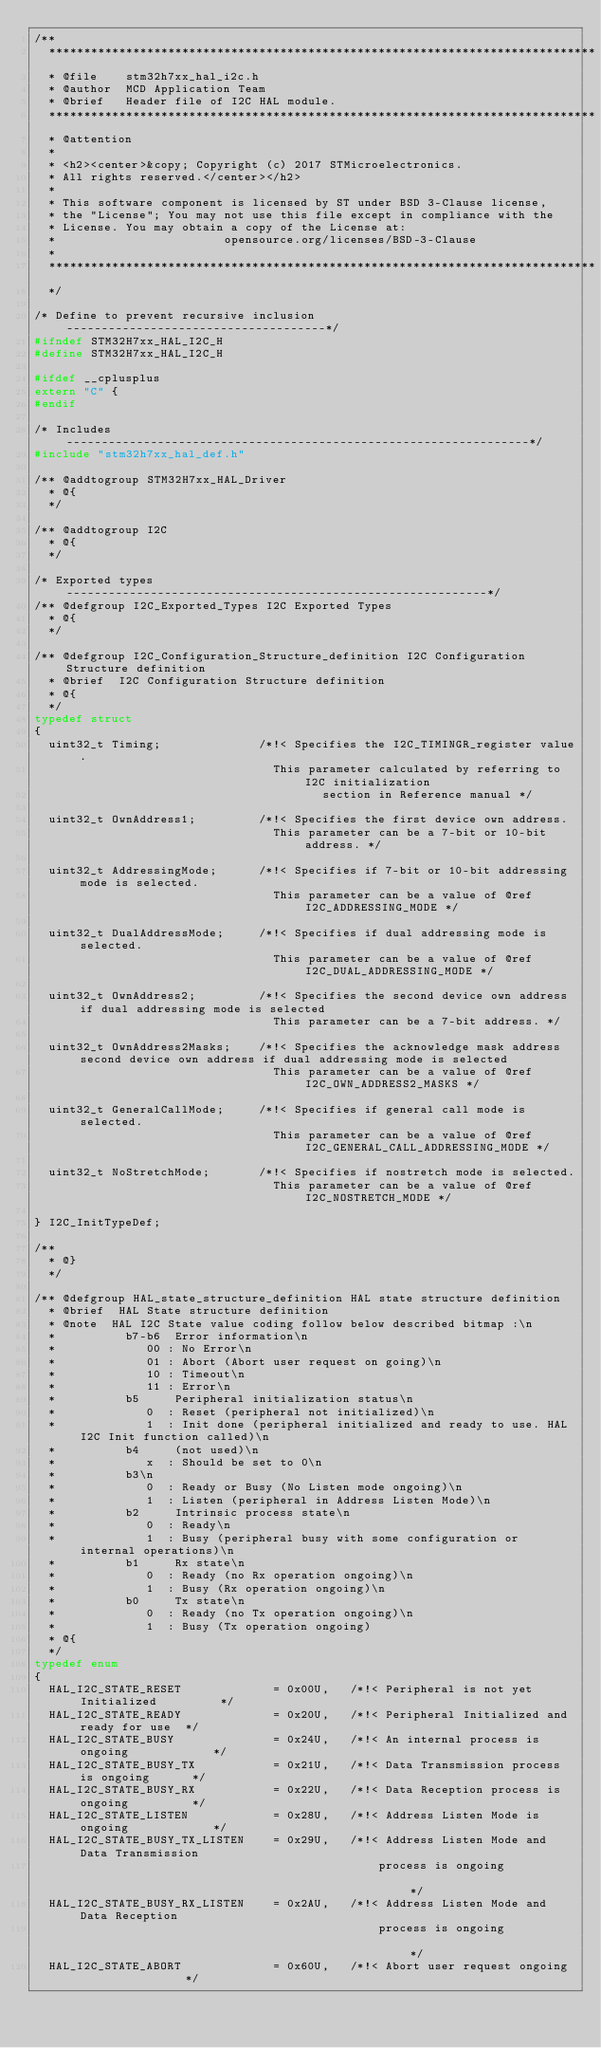<code> <loc_0><loc_0><loc_500><loc_500><_C_>/**
  ******************************************************************************
  * @file    stm32h7xx_hal_i2c.h
  * @author  MCD Application Team
  * @brief   Header file of I2C HAL module.
  ******************************************************************************
  * @attention
  *
  * <h2><center>&copy; Copyright (c) 2017 STMicroelectronics.
  * All rights reserved.</center></h2>
  *
  * This software component is licensed by ST under BSD 3-Clause license,
  * the "License"; You may not use this file except in compliance with the
  * License. You may obtain a copy of the License at:
  *                        opensource.org/licenses/BSD-3-Clause
  *
  ******************************************************************************
  */

/* Define to prevent recursive inclusion -------------------------------------*/
#ifndef STM32H7xx_HAL_I2C_H
#define STM32H7xx_HAL_I2C_H

#ifdef __cplusplus
extern "C" {
#endif

/* Includes ------------------------------------------------------------------*/
#include "stm32h7xx_hal_def.h"

/** @addtogroup STM32H7xx_HAL_Driver
  * @{
  */

/** @addtogroup I2C
  * @{
  */

/* Exported types ------------------------------------------------------------*/
/** @defgroup I2C_Exported_Types I2C Exported Types
  * @{
  */

/** @defgroup I2C_Configuration_Structure_definition I2C Configuration Structure definition
  * @brief  I2C Configuration Structure definition
  * @{
  */
typedef struct
{
  uint32_t Timing;              /*!< Specifies the I2C_TIMINGR_register value.
                                  This parameter calculated by referring to I2C initialization
                                         section in Reference manual */

  uint32_t OwnAddress1;         /*!< Specifies the first device own address.
                                  This parameter can be a 7-bit or 10-bit address. */

  uint32_t AddressingMode;      /*!< Specifies if 7-bit or 10-bit addressing mode is selected.
                                  This parameter can be a value of @ref I2C_ADDRESSING_MODE */

  uint32_t DualAddressMode;     /*!< Specifies if dual addressing mode is selected.
                                  This parameter can be a value of @ref I2C_DUAL_ADDRESSING_MODE */

  uint32_t OwnAddress2;         /*!< Specifies the second device own address if dual addressing mode is selected
                                  This parameter can be a 7-bit address. */

  uint32_t OwnAddress2Masks;    /*!< Specifies the acknowledge mask address second device own address if dual addressing mode is selected
                                  This parameter can be a value of @ref I2C_OWN_ADDRESS2_MASKS */

  uint32_t GeneralCallMode;     /*!< Specifies if general call mode is selected.
                                  This parameter can be a value of @ref I2C_GENERAL_CALL_ADDRESSING_MODE */

  uint32_t NoStretchMode;       /*!< Specifies if nostretch mode is selected.
                                  This parameter can be a value of @ref I2C_NOSTRETCH_MODE */

} I2C_InitTypeDef;

/**
  * @}
  */

/** @defgroup HAL_state_structure_definition HAL state structure definition
  * @brief  HAL State structure definition
  * @note  HAL I2C State value coding follow below described bitmap :\n
  *          b7-b6  Error information\n
  *             00 : No Error\n
  *             01 : Abort (Abort user request on going)\n
  *             10 : Timeout\n
  *             11 : Error\n
  *          b5     Peripheral initialization status\n
  *             0  : Reset (peripheral not initialized)\n
  *             1  : Init done (peripheral initialized and ready to use. HAL I2C Init function called)\n
  *          b4     (not used)\n
  *             x  : Should be set to 0\n
  *          b3\n
  *             0  : Ready or Busy (No Listen mode ongoing)\n
  *             1  : Listen (peripheral in Address Listen Mode)\n
  *          b2     Intrinsic process state\n
  *             0  : Ready\n
  *             1  : Busy (peripheral busy with some configuration or internal operations)\n
  *          b1     Rx state\n
  *             0  : Ready (no Rx operation ongoing)\n
  *             1  : Busy (Rx operation ongoing)\n
  *          b0     Tx state\n
  *             0  : Ready (no Tx operation ongoing)\n
  *             1  : Busy (Tx operation ongoing)
  * @{
  */
typedef enum
{
  HAL_I2C_STATE_RESET             = 0x00U,   /*!< Peripheral is not yet Initialized         */
  HAL_I2C_STATE_READY             = 0x20U,   /*!< Peripheral Initialized and ready for use  */
  HAL_I2C_STATE_BUSY              = 0x24U,   /*!< An internal process is ongoing            */
  HAL_I2C_STATE_BUSY_TX           = 0x21U,   /*!< Data Transmission process is ongoing      */
  HAL_I2C_STATE_BUSY_RX           = 0x22U,   /*!< Data Reception process is ongoing         */
  HAL_I2C_STATE_LISTEN            = 0x28U,   /*!< Address Listen Mode is ongoing            */
  HAL_I2C_STATE_BUSY_TX_LISTEN    = 0x29U,   /*!< Address Listen Mode and Data Transmission
                                                 process is ongoing                         */
  HAL_I2C_STATE_BUSY_RX_LISTEN    = 0x2AU,   /*!< Address Listen Mode and Data Reception
                                                 process is ongoing                         */
  HAL_I2C_STATE_ABORT             = 0x60U,   /*!< Abort user request ongoing                */</code> 